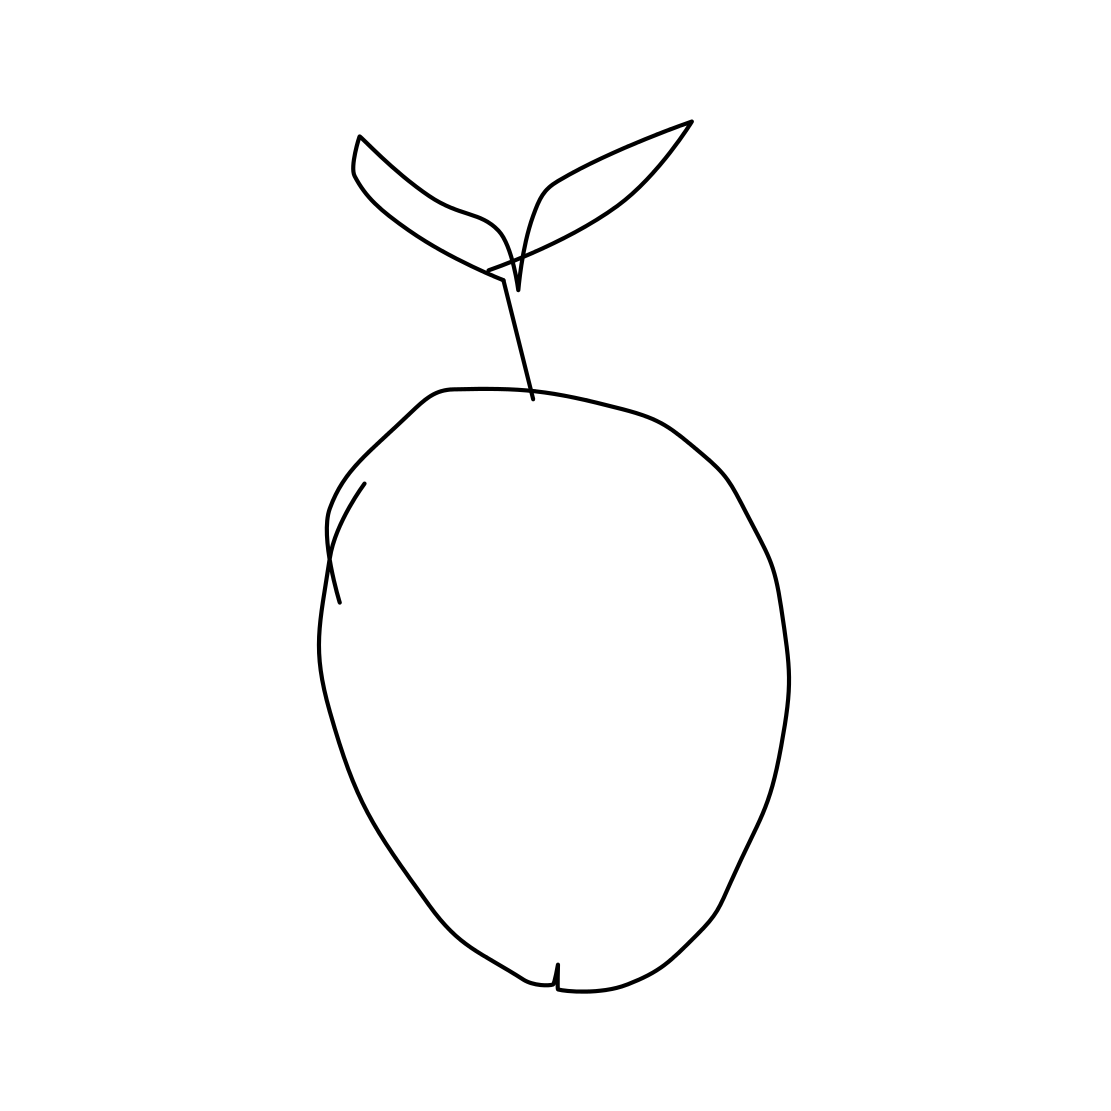Can you describe the artistic style used in this drawing? The artistic style of this drawing is minimalist and linear, utilizing clean, unbroken lines to form the shape of the apple and its leaves. This style emphasizes clarity and simplicity. 